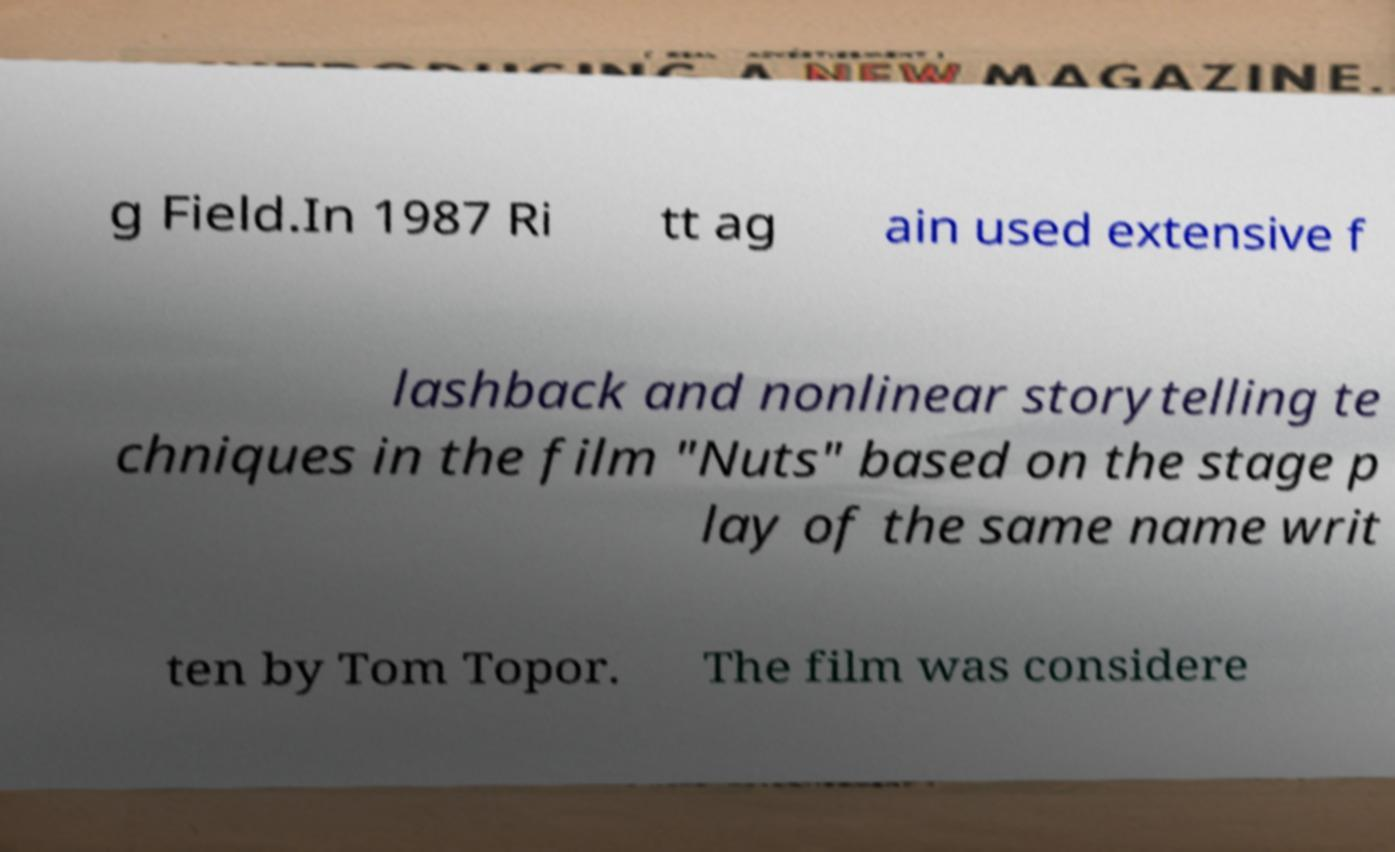Please read and relay the text visible in this image. What does it say? g Field.In 1987 Ri tt ag ain used extensive f lashback and nonlinear storytelling te chniques in the film "Nuts" based on the stage p lay of the same name writ ten by Tom Topor. The film was considere 